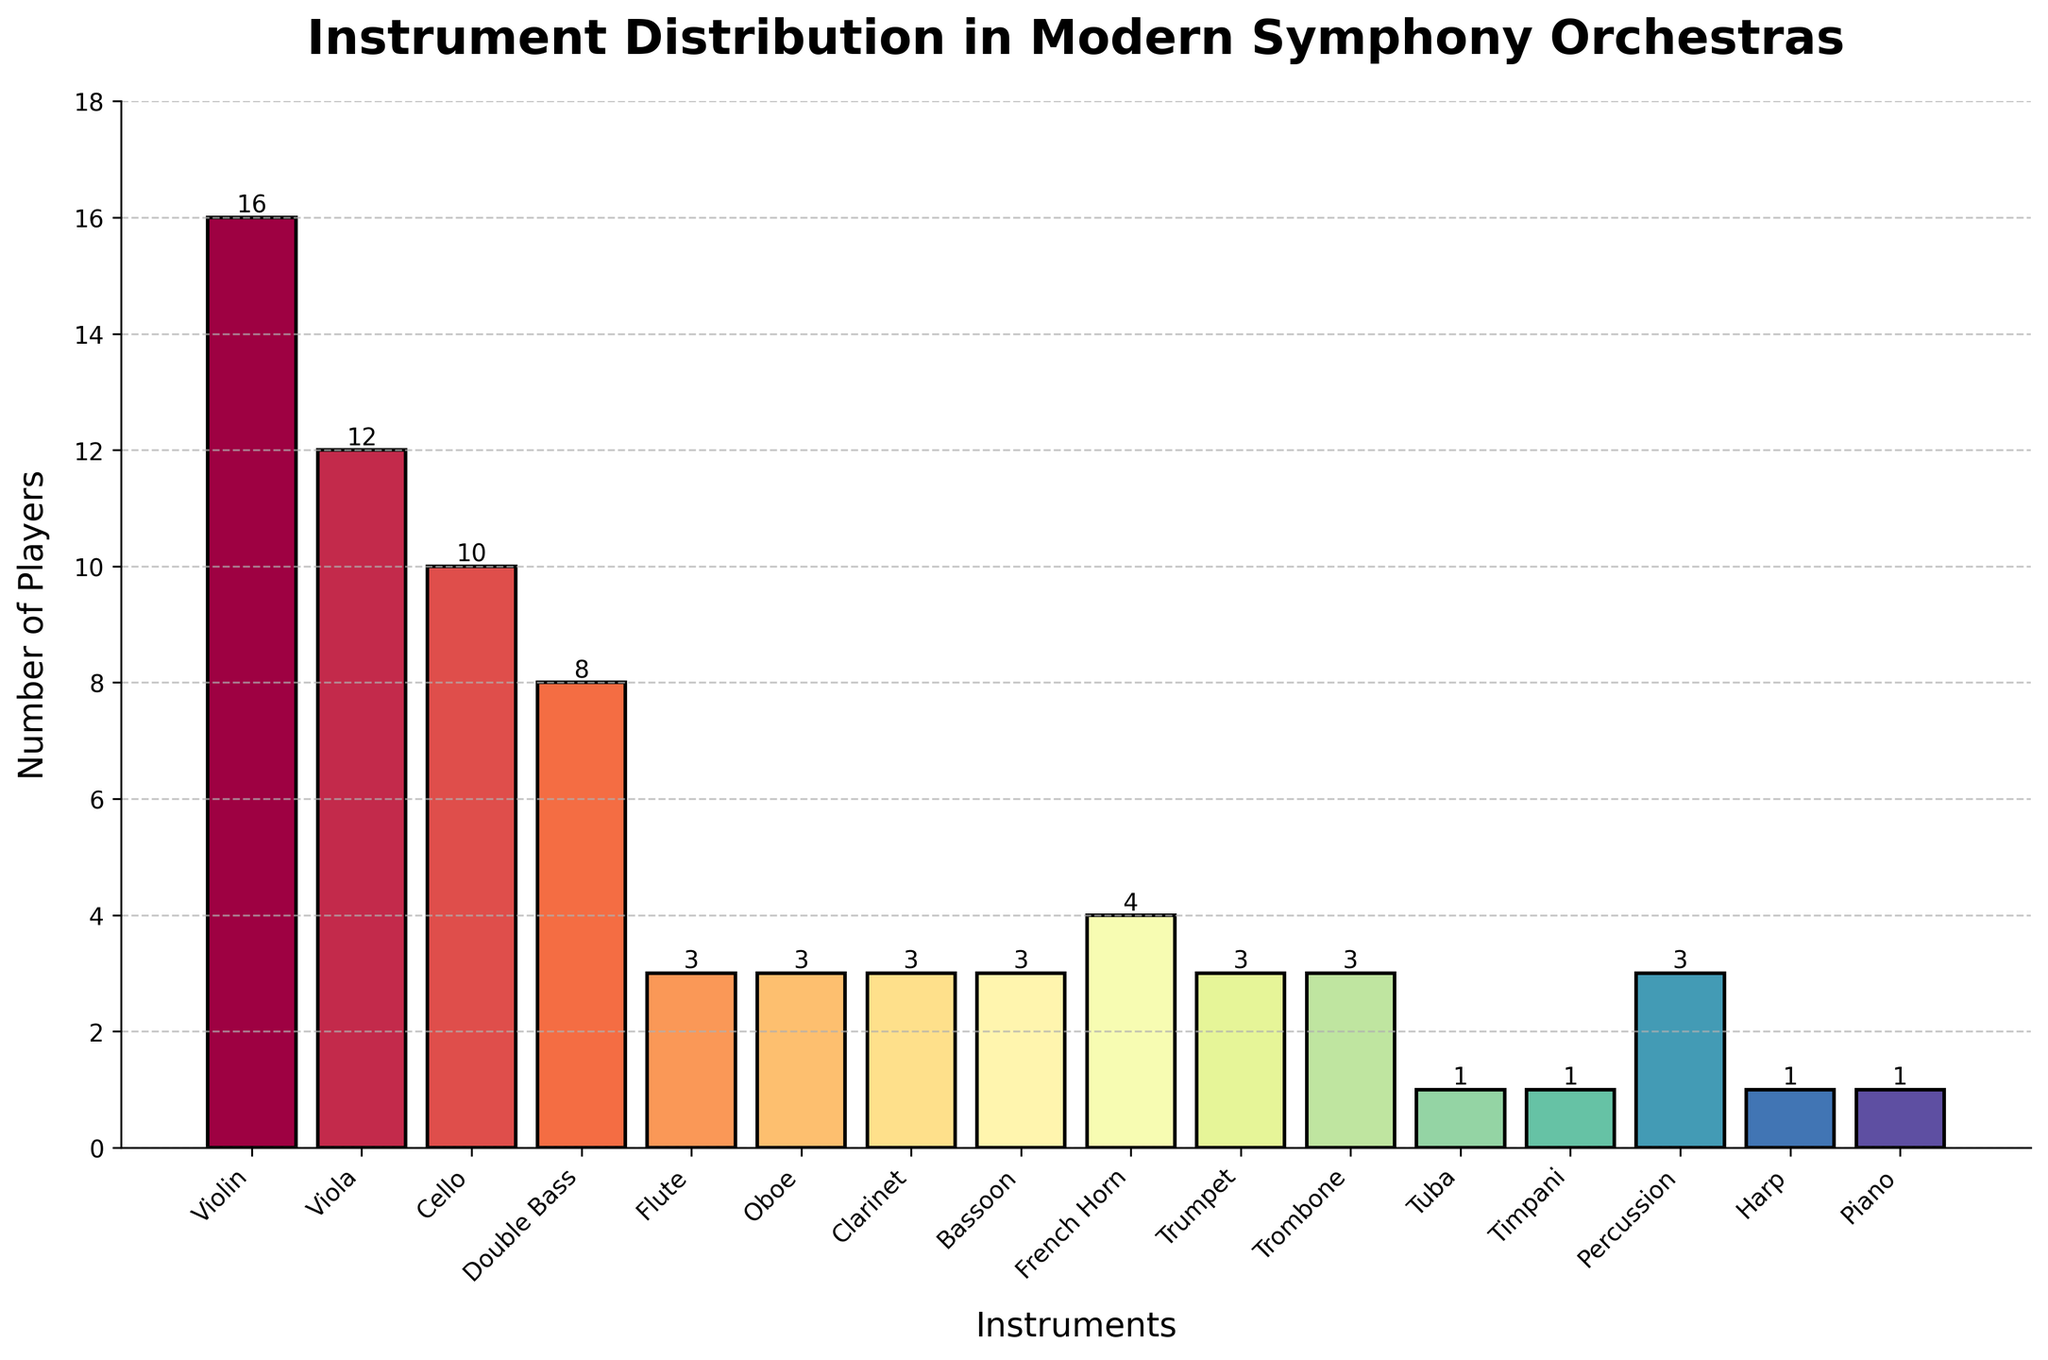Which instrument has the greatest number of players? By observing the height of the bars in the bar chart, the violin has the highest bar, indicating the greatest number of players.
Answer: Violin How many more violin players are there than double bass players? The bar chart shows 16 violin players and 8 double bass players. The difference is calculated as 16 - 8 = 8.
Answer: 8 Which instrument has the fewest players? By observing the smallest bars, the tuba, timpani, harp, and piano each have the shortest bars, indicating only one player each.
Answer: Tuba, Timpani, Harp, Piano Are there more brass or woodwind players? Brass instruments: French Horn (4), Trumpet (3), Trombone (3), Tuba (1). Total brass players = 4 + 3 + 3 + 1 = 11. Woodwind instruments: Flute (3), Oboe (3), Clarinet (3), Bassoon (3). Total woodwind players = 3 + 3 + 3 + 3 = 12.
Answer: Woodwind What's the total number of string players in the orchestra? The bar chart shows violin (16), viola (12), cello (10), and double bass (8). Summing these gives 16 + 12 + 10 + 8 = 46.
Answer: 46 What's the average number of players across all listed instruments? Sum all players: 16 + 12 + 10 + 8 + 3 + 3 + 3 + 3 + 4 + 3 + 3 + 1 + 1 + 3 + 1 + 1 = 75. There are 16 instruments, so the average is 75 / 16 ≈ 4.69.
Answer: 4.69 By how much do percussion players outnumber tuba players? The bar chart indicates 3 percussion players and 1 tuba player. The difference is 3 - 1 = 2.
Answer: 2 Which is more: the number of cello and double bass players combined, or violin players alone? Cello players: 10, double bass players: 8. Combined = 10 + 8 = 18. Violin players: 16. Comparing 18 and 16, 18 is greater.
Answer: Combined (18) Which instrument's bar stands out in the color spectrum the most? This is subjective, but typically, a color like red or a very bright color tends to stand out. Observing the chart, identify the brightest or most distinct color bar.
Answer: (Subjective based on color scheme but could be "Violin" if it's a distinct color) What’s the sum of the players for instruments with only one player each? The chart shows tuba, timpani, harp, and piano each with 1 player. Summing these gives 1 + 1 + 1 + 1 = 4.
Answer: 4 How does the height of the bar for viola compare to the bar for flute? The bar chart shows 12 players for viola and 3 players for flute. The viola bar is taller.
Answer: Taller Which has more players: the combination of all woodwind instruments (flute, oboe, clarinet, bassoon) or all brass instruments (French horn, trumpet, trombone, tuba)? Woodwinds total 12 (3 + 3 + 3 + 3), brass total 11 (4 + 3 + 3 + 1). Comparing totals, 12 is greater.
Answer: Woodwinds What's the difference between the sum of percussion and timpani players and the sum of viola and cello players? Percussion: 3, timpani: 1, viola: 12, cello: 10. Sum percussion and timpani: 3 + 1 = 4. Sum viola and cello: 12 + 10 = 22. Difference: 22 - 4 = 18.
Answer: 18 